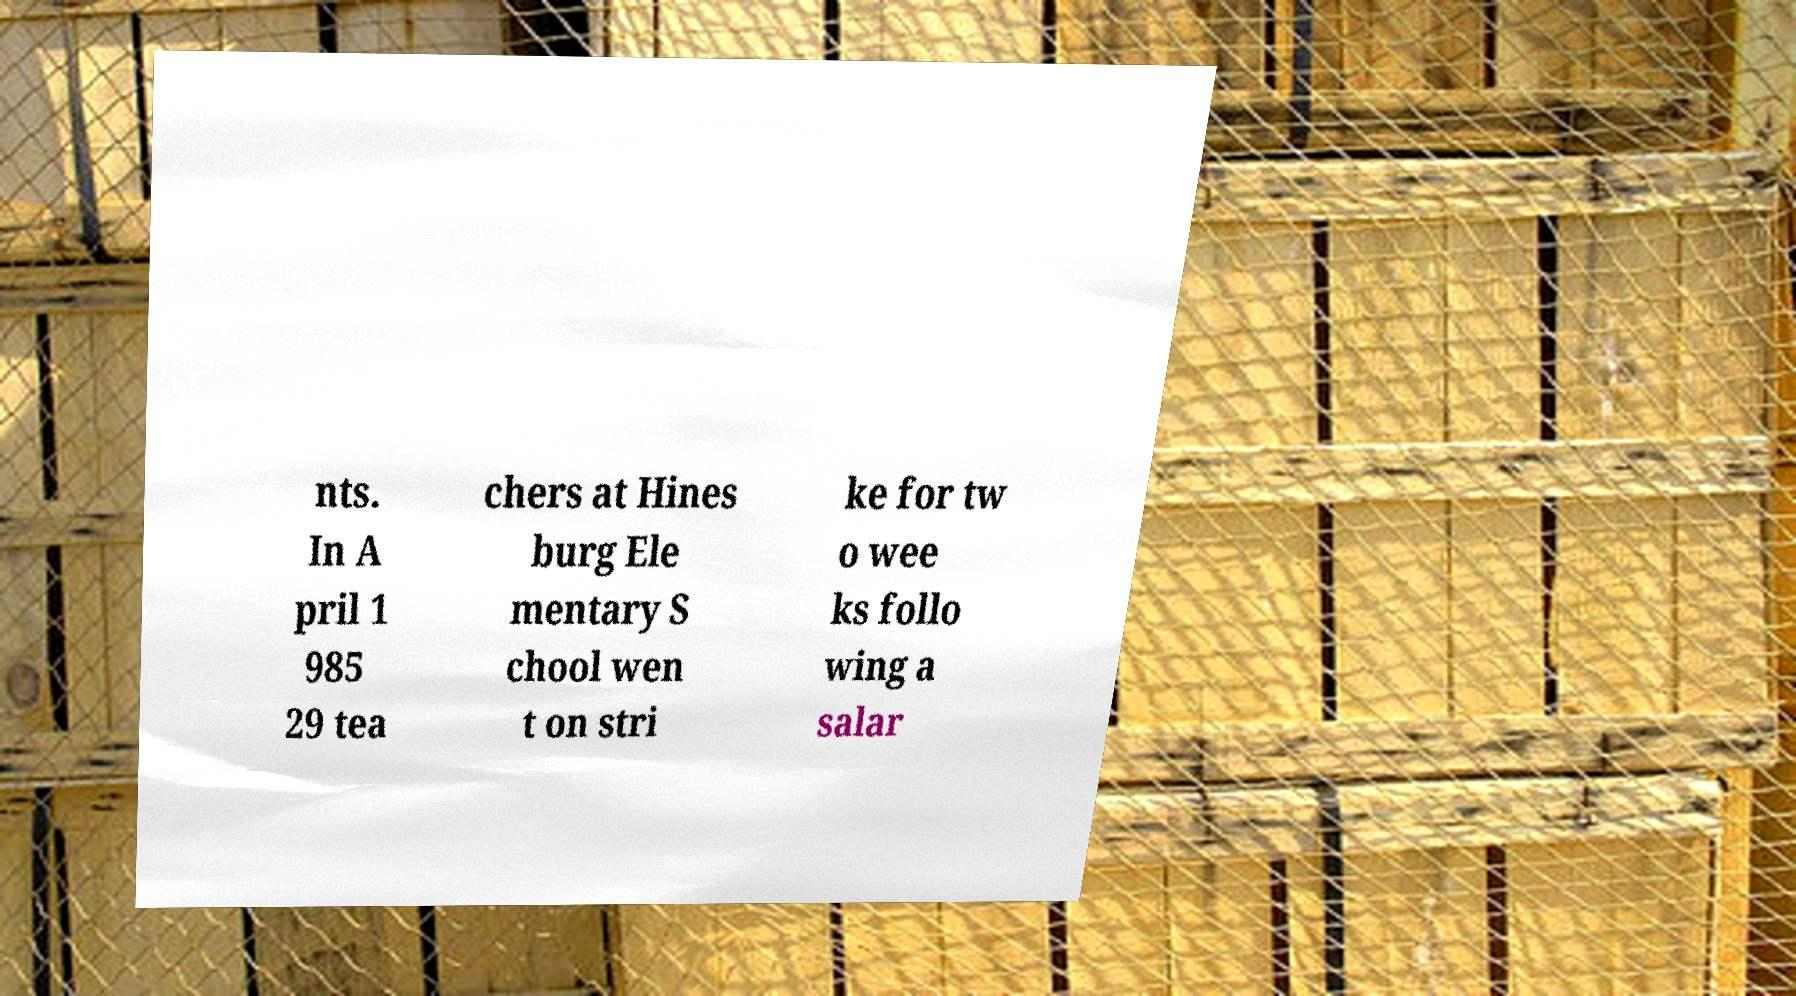Could you assist in decoding the text presented in this image and type it out clearly? nts. In A pril 1 985 29 tea chers at Hines burg Ele mentary S chool wen t on stri ke for tw o wee ks follo wing a salar 